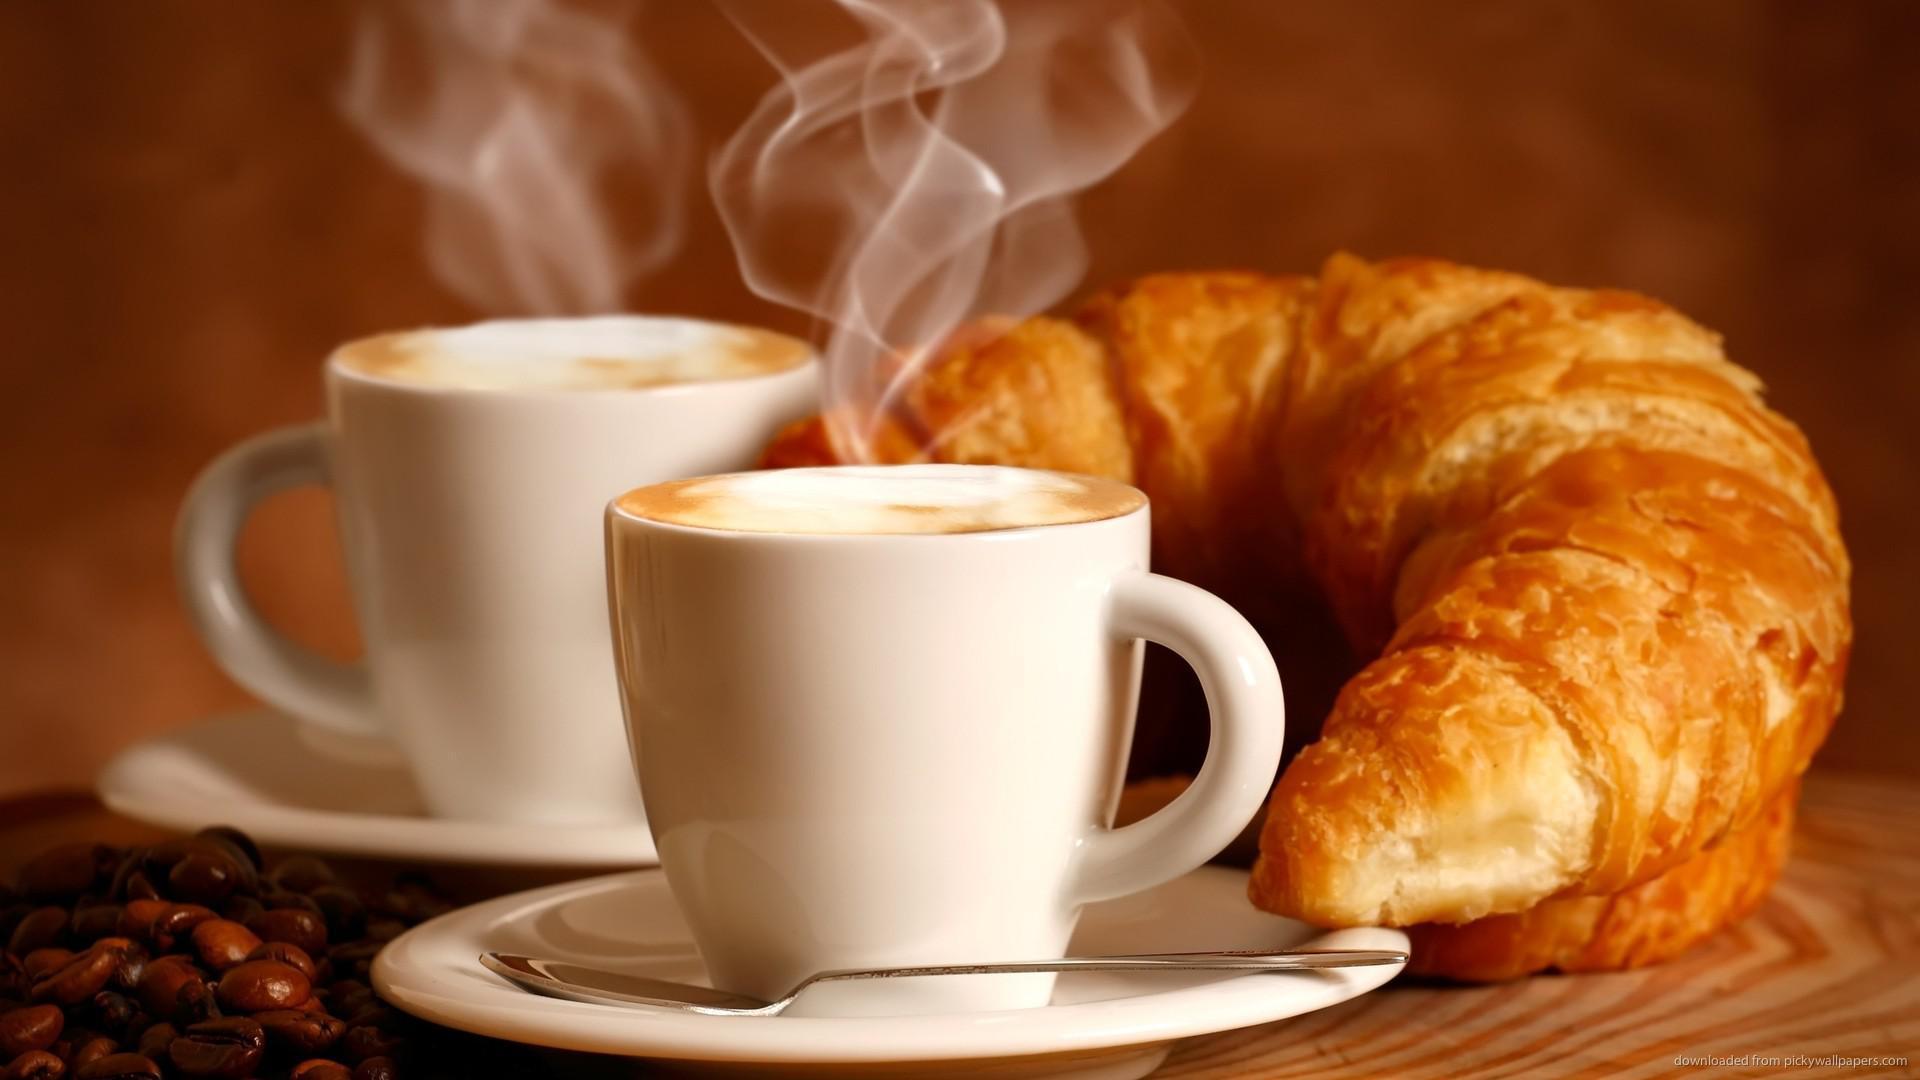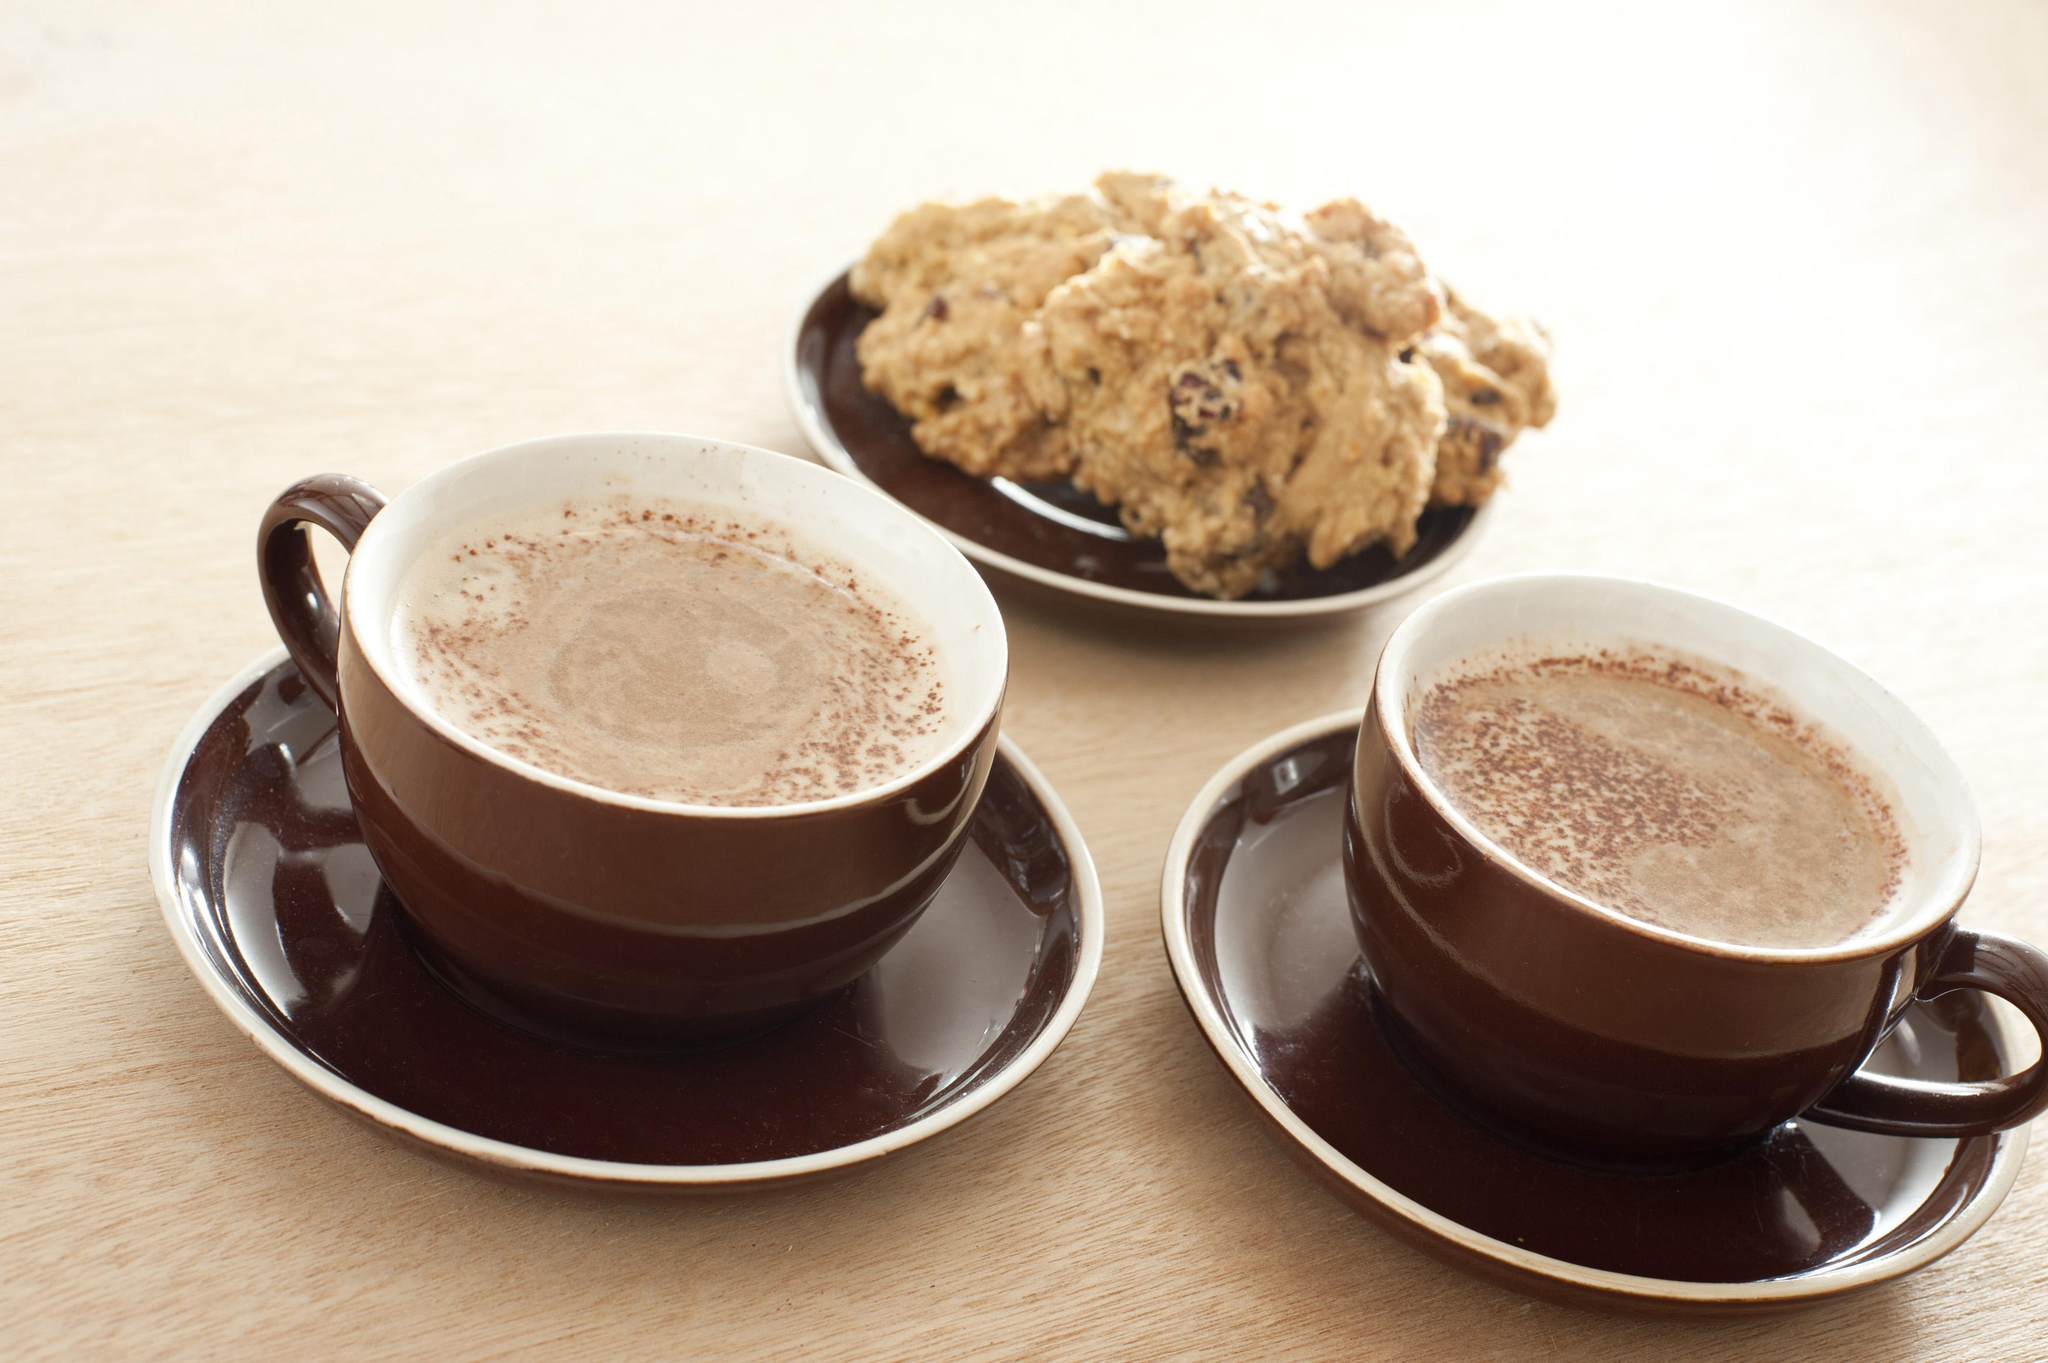The first image is the image on the left, the second image is the image on the right. Given the left and right images, does the statement "Several coffee beans are near a white cup of steaming beverage on a white saucer." hold true? Answer yes or no. Yes. The first image is the image on the left, the second image is the image on the right. Analyze the images presented: Is the assertion "All of the mugs are sitting on saucers." valid? Answer yes or no. Yes. 